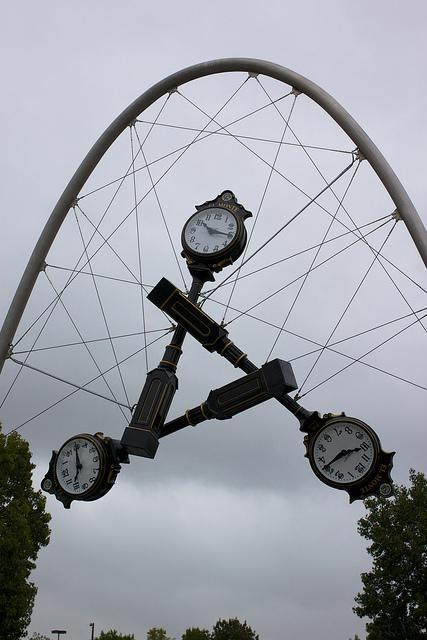Why are the clocks all facing different directions?
Select the accurate response from the four choices given to answer the question.
Options: Easier reading, gimmick, broken, different times. Gimmick. 